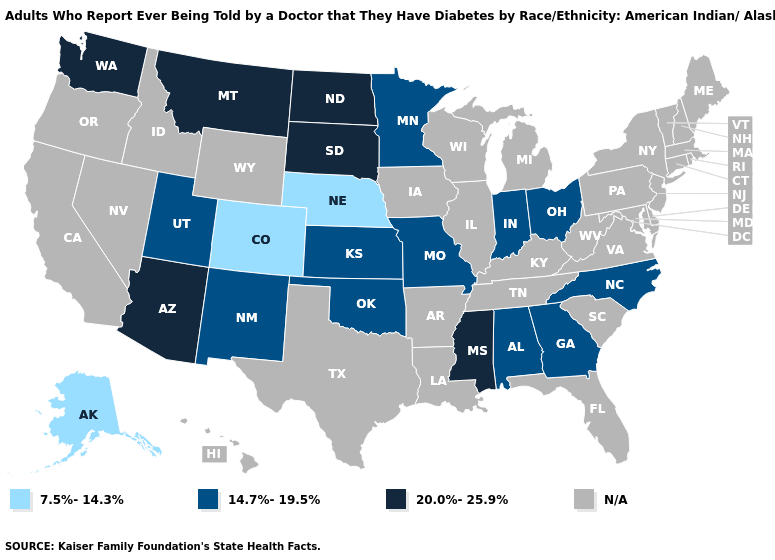Name the states that have a value in the range N/A?
Answer briefly. Arkansas, California, Connecticut, Delaware, Florida, Hawaii, Idaho, Illinois, Iowa, Kentucky, Louisiana, Maine, Maryland, Massachusetts, Michigan, Nevada, New Hampshire, New Jersey, New York, Oregon, Pennsylvania, Rhode Island, South Carolina, Tennessee, Texas, Vermont, Virginia, West Virginia, Wisconsin, Wyoming. Name the states that have a value in the range 7.5%-14.3%?
Short answer required. Alaska, Colorado, Nebraska. Among the states that border Illinois , which have the highest value?
Write a very short answer. Indiana, Missouri. Does Minnesota have the lowest value in the USA?
Answer briefly. No. Does South Dakota have the highest value in the MidWest?
Quick response, please. Yes. Name the states that have a value in the range 14.7%-19.5%?
Concise answer only. Alabama, Georgia, Indiana, Kansas, Minnesota, Missouri, New Mexico, North Carolina, Ohio, Oklahoma, Utah. What is the value of Arizona?
Quick response, please. 20.0%-25.9%. Which states hav the highest value in the South?
Give a very brief answer. Mississippi. What is the value of Arkansas?
Write a very short answer. N/A. Does Oklahoma have the highest value in the South?
Write a very short answer. No. What is the value of Wisconsin?
Keep it brief. N/A. What is the value of Colorado?
Be succinct. 7.5%-14.3%. Name the states that have a value in the range 7.5%-14.3%?
Write a very short answer. Alaska, Colorado, Nebraska. 